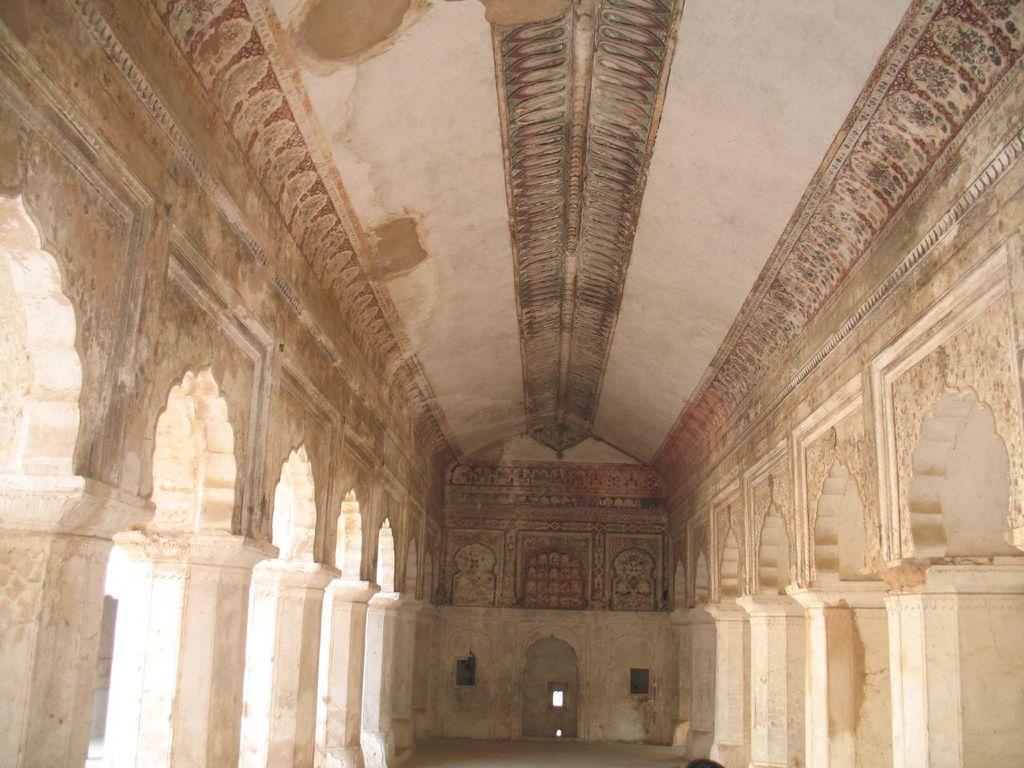Could you give a brief overview of what you see in this image? This image consists of a wall along with pillars. There are many arches to the left and right. 